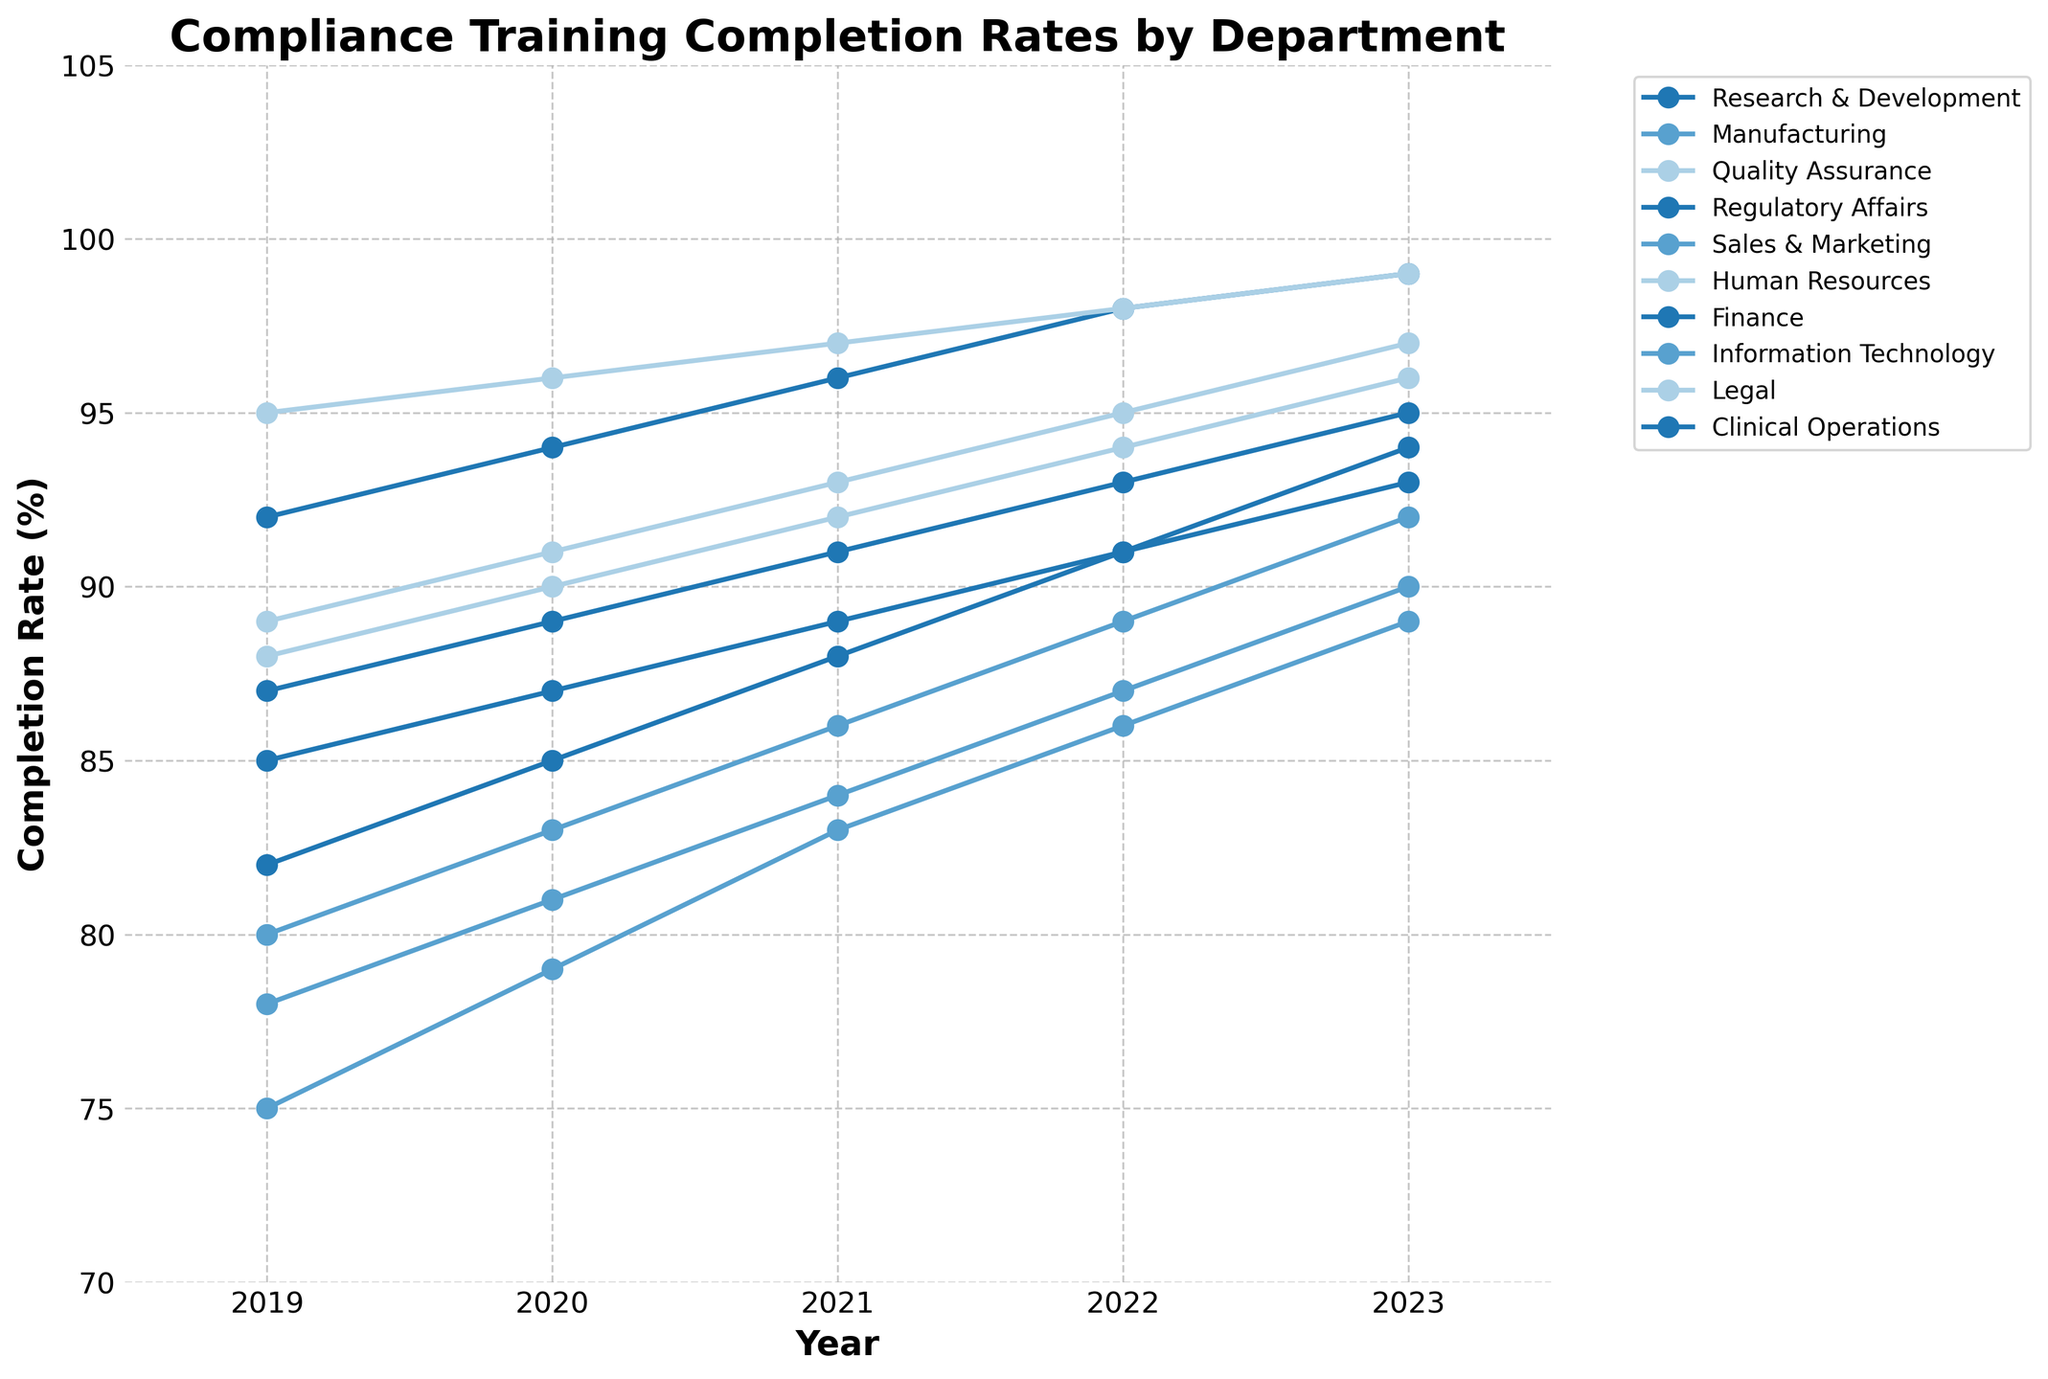What was the compliance training completion rate of the Manufacturing department in 2021? Locate the Manufacturing department's line on the chart and find the point corresponding to the year 2021. The completion rate is the value of that point.
Answer: 84 Which department showed the highest completion rate in 2023? Look for the department whose line ends at the highest point in the year 2023.
Answer: Regulatory Affairs and Legal By how much did the Finance department's completion rate increase between 2019 and 2023? Find the completion rates for the Finance department in 2019 and in 2023, then subtract the former from the latter: 93 - 85 = 8
Answer: 8 Which department had the lowest initial compliance training completion rate in 2019, and what was that rate? Look for the lowest point among all departments in the year 2019.
Answer: Sales & Marketing, 75 How many departments had a completion rate of 95% or higher by 2023? Count the number of departments whose completion rate reached 95% or above in the year 2023.
Answer: 5 What is the average compliance training completion rate of the Sales & Marketing department from 2019 to 2023? Add the completion rates for each year from 2019 to 2023: (75 + 79 + 83 + 86 + 89), then divide by 5.
Answer: 82.4 Compare the compliance training completion trends between the Research & Development and Clinical Operations departments. Which department saw a greater increase from 2019 to 2023? Calculate the increase for Research & Development (94 - 82) and Clinical Operations (95 - 87), then compare.
Answer: Research & Development Which department showed a steady increase in compliance training completion every year? Identify the department(s) with a consistently increasing line from 2019 to 2023.
Answer: Research & Development, Manufacturing, Sales & Marketing, Information Technology, Clinical Operations What was the completion rate trend for Quality Assurance from 2019 to 2023, and how does it compare to Human Resources? Examine the trend of both departments. Quality Assurance starts at 89 and reaches 97; Human Resources starts at 88 and reaches 96. Both show a steady increase, with Quality Assurance consistently higher.
Answer: Steady increase, Quality Assurance had higher rates 